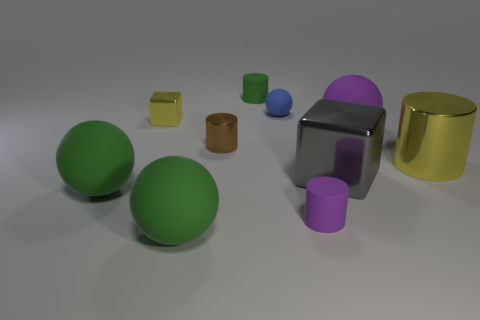What size is the green object that is the same shape as the small brown object?
Your answer should be very brief. Small. Are any purple metallic things visible?
Offer a very short reply. No. What number of objects are either spheres to the left of the large yellow metal thing or tiny blue spheres?
Offer a very short reply. 4. What material is the ball that is the same size as the brown cylinder?
Make the answer very short. Rubber. What color is the large metal object in front of the metallic thing that is right of the gray metal block?
Offer a terse response. Gray. There is a blue ball; what number of tiny green cylinders are on the left side of it?
Provide a short and direct response. 1. What is the color of the small metal block?
Make the answer very short. Yellow. What number of tiny things are red matte cylinders or brown shiny objects?
Your answer should be compact. 1. There is a sphere behind the purple sphere; does it have the same color as the cylinder in front of the large gray metal block?
Offer a terse response. No. How many other things are the same color as the small shiny block?
Provide a succinct answer. 1. 